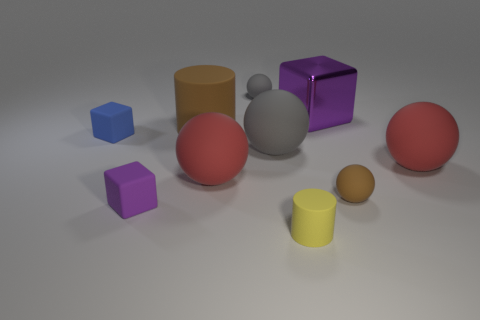What size is the matte ball that is the same color as the large matte cylinder?
Keep it short and to the point. Small. Are there any tiny yellow matte objects behind the big red rubber sphere that is on the left side of the big purple block?
Provide a short and direct response. No. Are there an equal number of gray matte balls that are on the left side of the small purple matte block and small red shiny cylinders?
Offer a very short reply. Yes. There is a purple block right of the brown object behind the small brown object; how many matte balls are in front of it?
Your response must be concise. 4. Is there a yellow object of the same size as the blue matte thing?
Your answer should be compact. Yes. Is the number of tiny matte cylinders that are behind the small blue rubber block less than the number of small red matte spheres?
Keep it short and to the point. No. What is the material of the gray ball in front of the brown thing to the left of the small sphere right of the small gray matte sphere?
Your answer should be compact. Rubber. Is the number of big brown cylinders to the left of the tiny purple object greater than the number of small gray matte balls to the right of the blue rubber block?
Your response must be concise. No. What number of rubber things are yellow things or purple things?
Give a very brief answer. 2. The tiny rubber object that is the same color as the large metal cube is what shape?
Your response must be concise. Cube. 